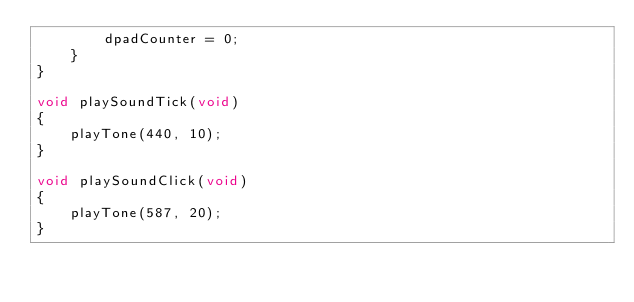<code> <loc_0><loc_0><loc_500><loc_500><_C++_>        dpadCounter = 0;
    }
}

void playSoundTick(void)
{
    playTone(440, 10);
}

void playSoundClick(void)
{
    playTone(587, 20);
}
</code> 